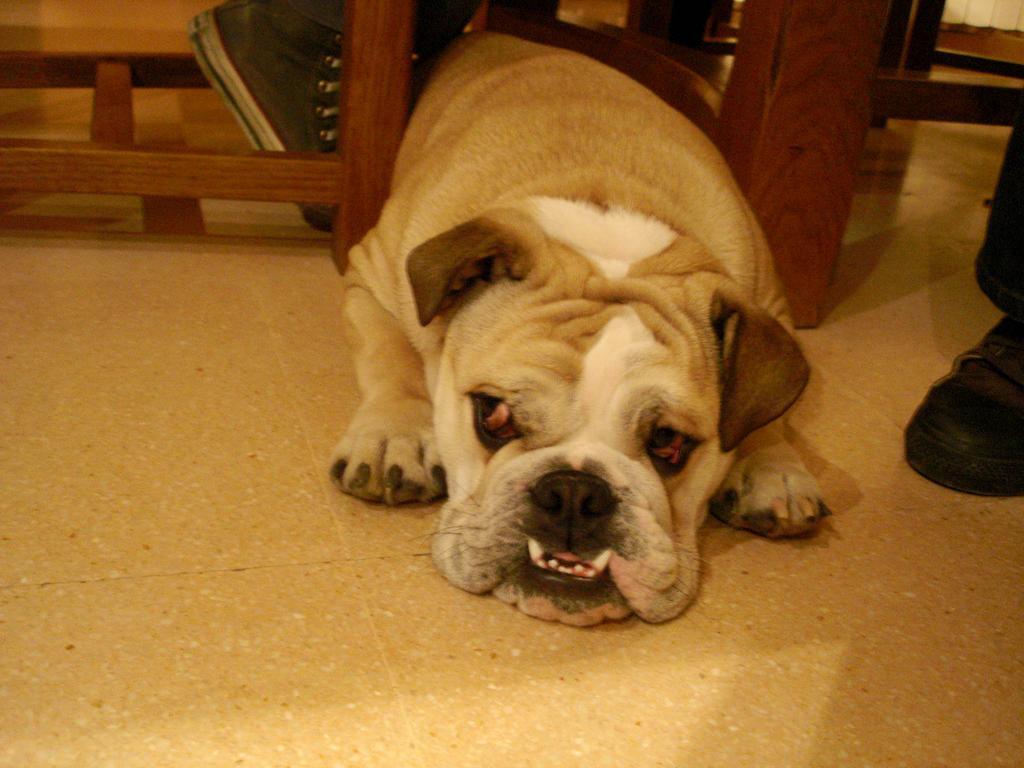How would you summarize this image in a sentence or two? In the middle of the image, there is a dog laying on the floor. Beside this dog, there is a wooden object. On the right side, there is a person wearing a shoe. 